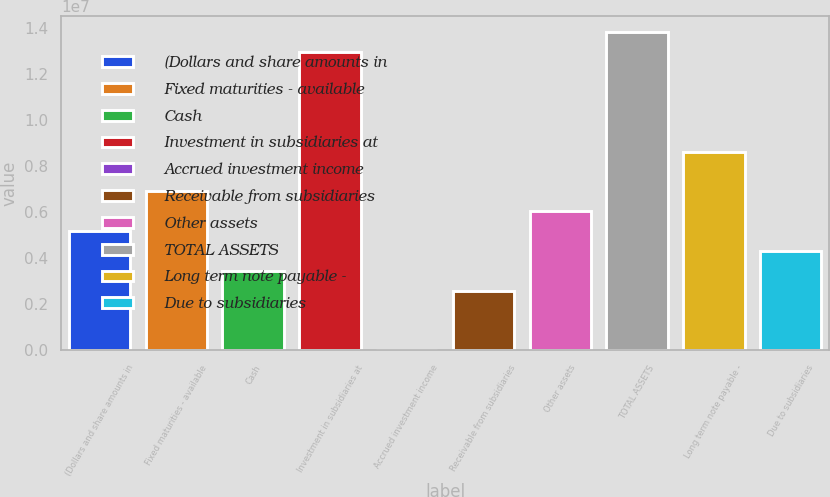<chart> <loc_0><loc_0><loc_500><loc_500><bar_chart><fcel>(Dollars and share amounts in<fcel>Fixed maturities - available<fcel>Cash<fcel>Investment in subsidiaries at<fcel>Accrued investment income<fcel>Receivable from subsidiaries<fcel>Other assets<fcel>TOTAL ASSETS<fcel>Long term note payable -<fcel>Due to subsidiaries<nl><fcel>5.17321e+06<fcel>6.89759e+06<fcel>3.44883e+06<fcel>1.29329e+07<fcel>71<fcel>2.58664e+06<fcel>6.0354e+06<fcel>1.37951e+07<fcel>8.62197e+06<fcel>4.31102e+06<nl></chart> 